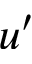Convert formula to latex. <formula><loc_0><loc_0><loc_500><loc_500>u ^ { \prime }</formula> 